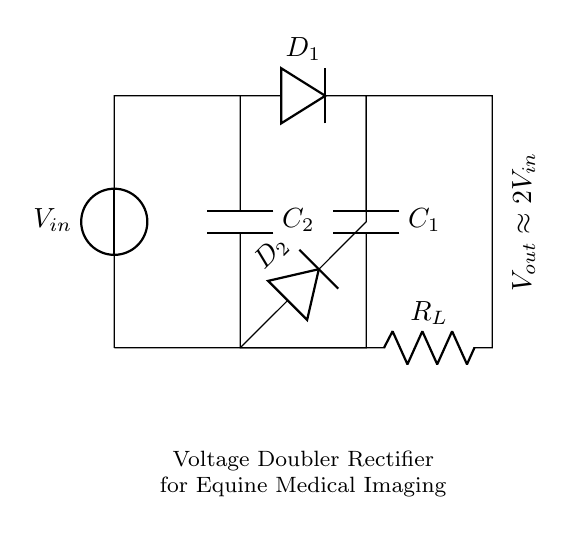What type of rectifying components are used in this circuit? The circuit uses two diodes, D1 and D2, which are the rectifying components for converting AC input to DC output.
Answer: Diodes What is the purpose of capacitor C1 in this rectifier circuit? C1 smoothens the output voltage by storing charge and releasing it, which helps in reducing voltage fluctuations, especially after rectification.
Answer: Smoothen output How many input capacitors are present in the circuit? There are two capacitors, C1 and C2, which are used in tandem for voltage doubling and stabilizing the output.
Answer: Two capacitors What is the expected output voltage in relation to the input voltage? The expected output voltage is approximately double the input voltage due to the configuration of the voltage doubler rectifier setup.
Answer: Approximately double Why is there a load resistor R_L in this circuit? R_L is used to simulate a load for the output voltage of the rectifier, allowing measurement of the output voltage under load conditions, which represents real-world usage.
Answer: Simulate load What is the primary application of this voltage doubler rectifier? This circuit is mainly used for high-voltage applications, particularly in equine medical imaging devices, where a high and stable output voltage is necessary for operation.
Answer: Equine medical imaging 